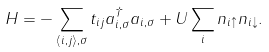<formula> <loc_0><loc_0><loc_500><loc_500>H = - \sum _ { \langle i , j \rangle , \sigma } t _ { i j } a _ { i , \sigma } ^ { \dagger } a _ { i , \sigma } + U \sum _ { i } n _ { i \uparrow } n _ { i \downarrow } .</formula> 